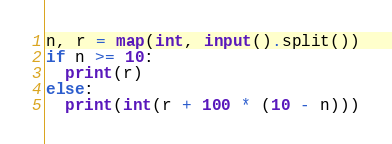Convert code to text. <code><loc_0><loc_0><loc_500><loc_500><_Python_>n, r = map(int, input().split())
if n >= 10:
  print(r)
else:
  print(int(r + 100 * (10 - n)))</code> 